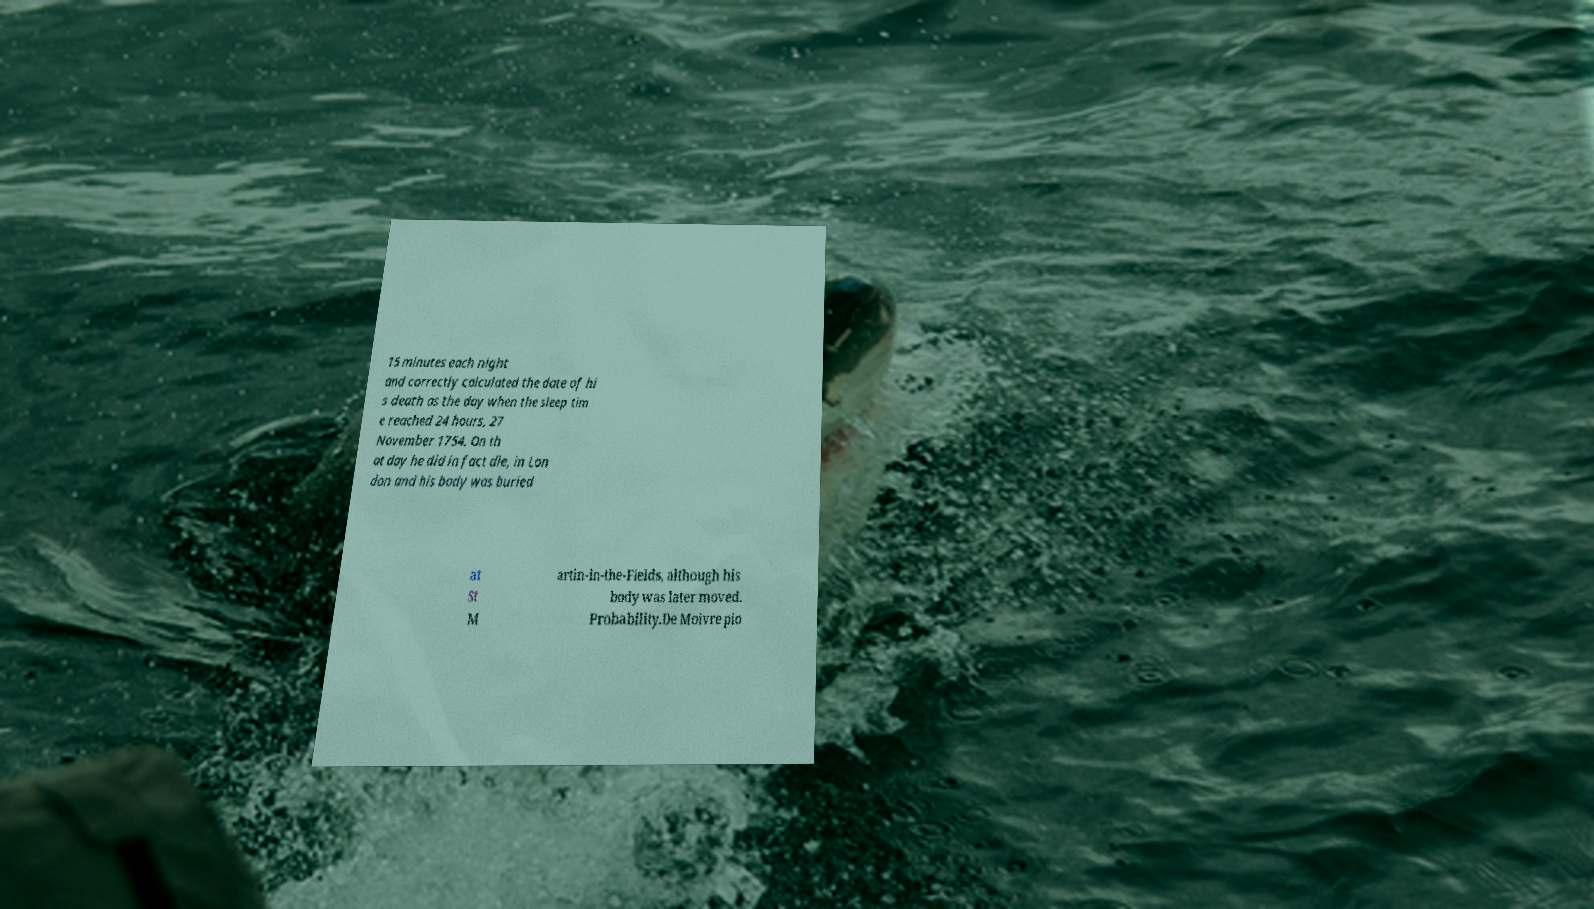For documentation purposes, I need the text within this image transcribed. Could you provide that? 15 minutes each night and correctly calculated the date of hi s death as the day when the sleep tim e reached 24 hours, 27 November 1754. On th at day he did in fact die, in Lon don and his body was buried at St M artin-in-the-Fields, although his body was later moved. Probability.De Moivre pio 